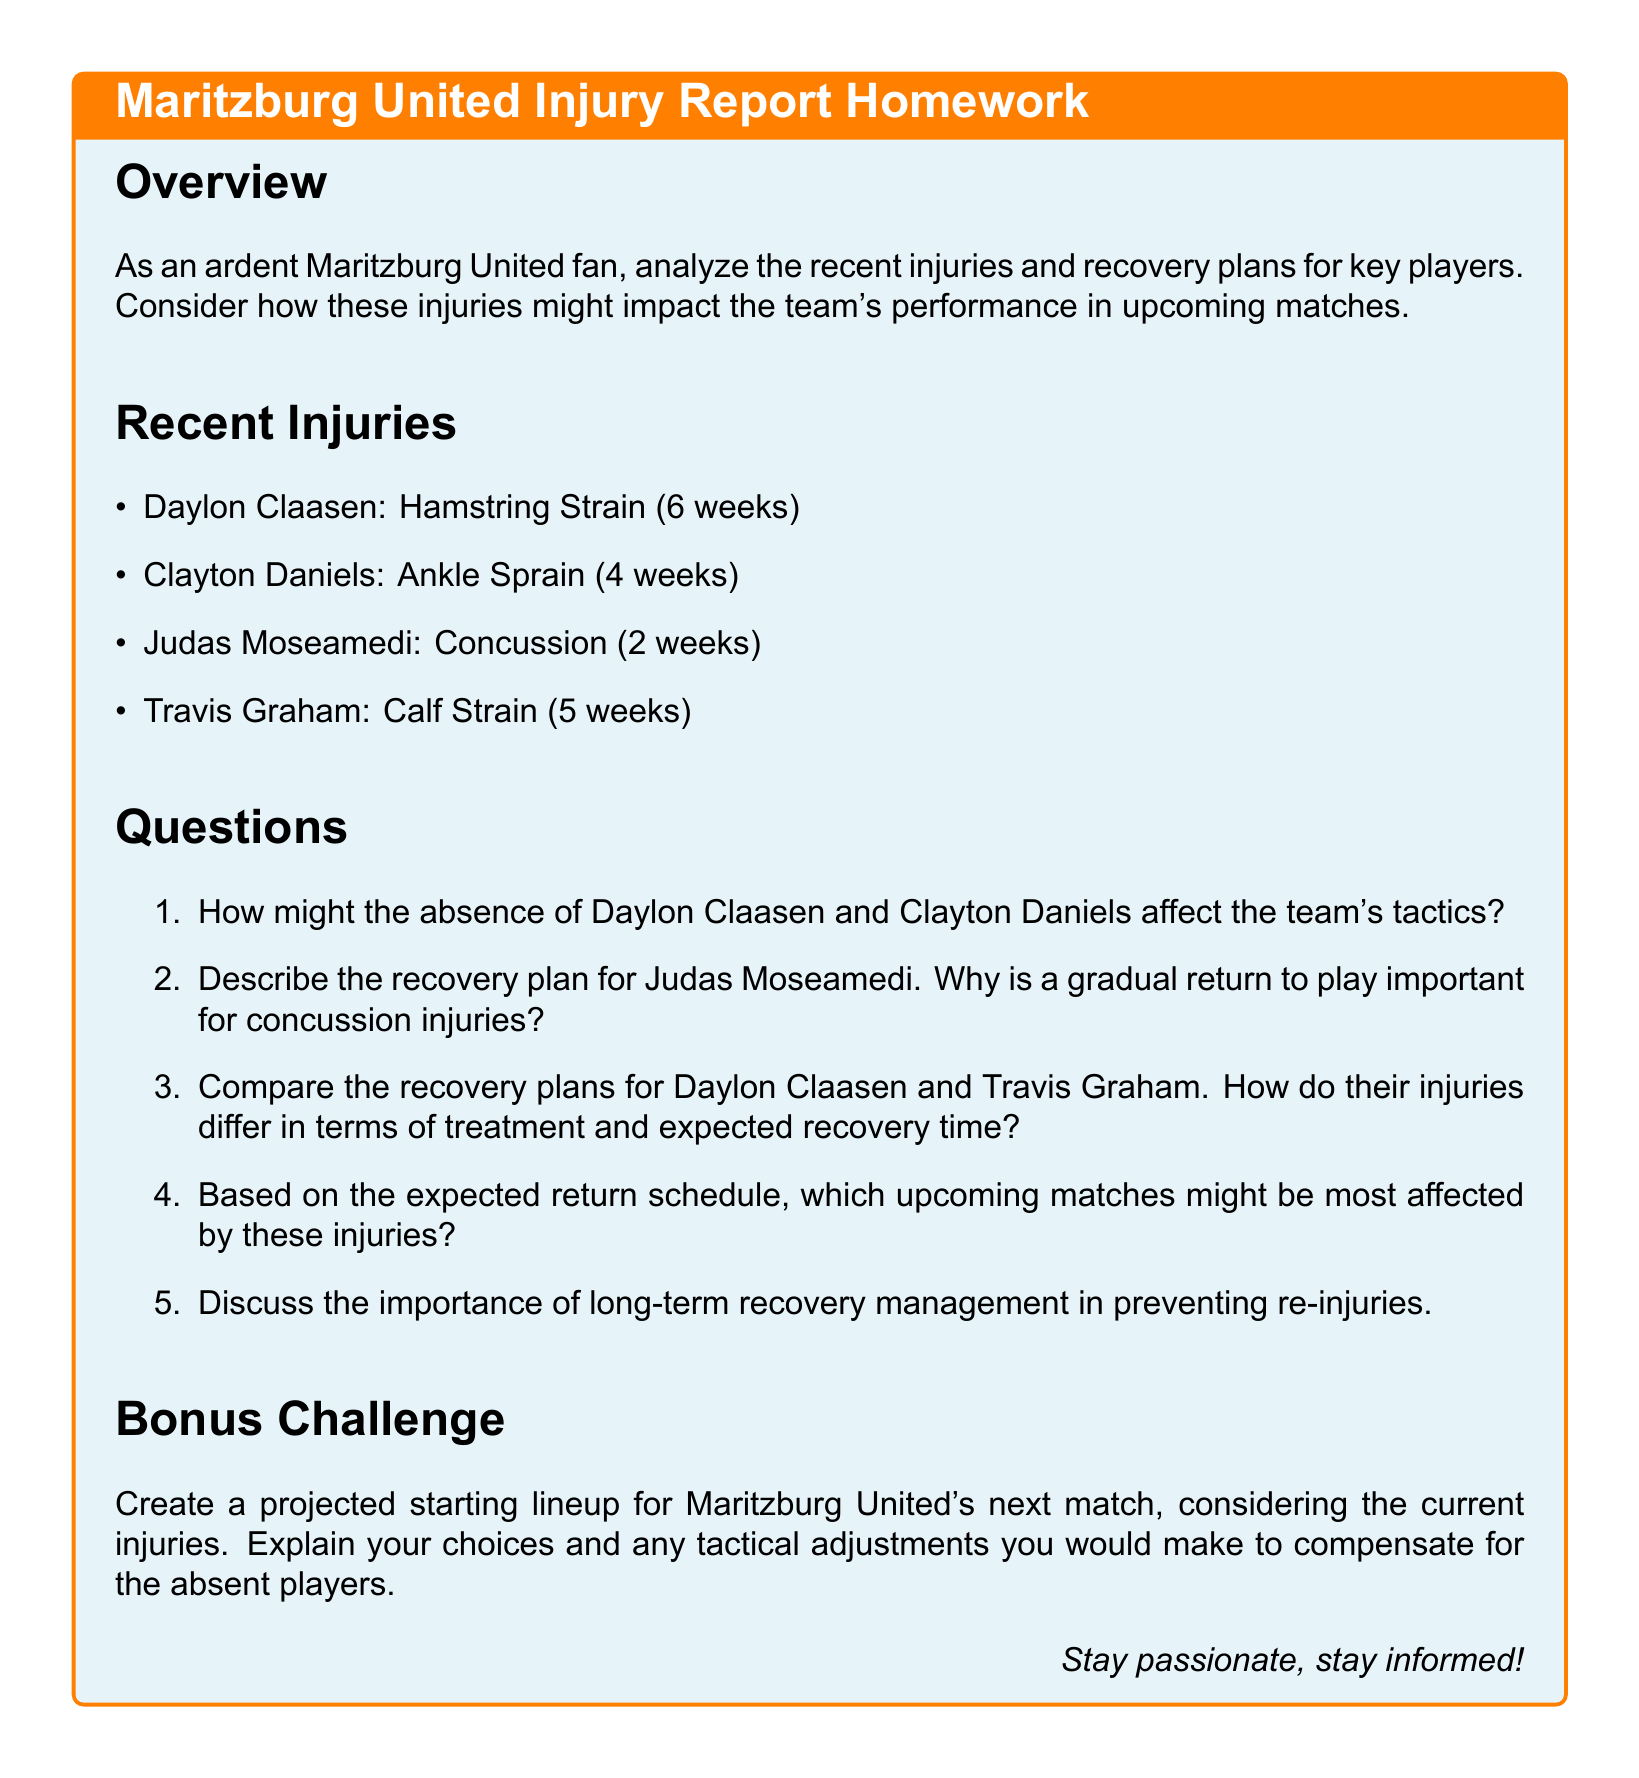What is the injury type for Daylon Claasen? Daylon Claasen is listed with a Hamstring Strain in the recent injuries section.
Answer: Hamstring Strain How long is Clayton Daniels expected to be out? The document specifies that Clayton Daniels has an Ankle Sprain and is expected to be out for 4 weeks.
Answer: 4 weeks How many weeks is Travis Graham's recovery plan? Travis Graham's injury, a Calf Strain, has a recovery plan of 5 weeks as noted in the document.
Answer: 5 weeks What is the recovery time for Judas Moseamedi's concussion? The recovery time mentioned for Judas Moseamedi's concussion is 2 weeks according to the document.
Answer: 2 weeks Which player has the longest recovery time? By comparing the recovery times listed, Daylon Claasen has the longest recovery time of 6 weeks.
Answer: Daylon Claasen Why is gradual return to play important for concussion injuries? The document implies that a gradual return to play is crucial for safety and full recovery from concussion injuries.
Answer: Safety How might the absence of Daylon Claasen affect team tactics? The document prompts analysis but does not provide a direct answer; the absence of a key player typically leads to tactical adjustments.
Answer: Tactical adjustments What is the bonus challenge in the homework? The bonus challenge asks to create a projected starting lineup for Maritzburg United's next match considering the current injuries.
Answer: Projected starting lineup What significant concern is highlighted regarding long-term recovery? The document emphasizes the importance of long-term recovery management in preventing re-injuries.
Answer: Preventing re-injuries 